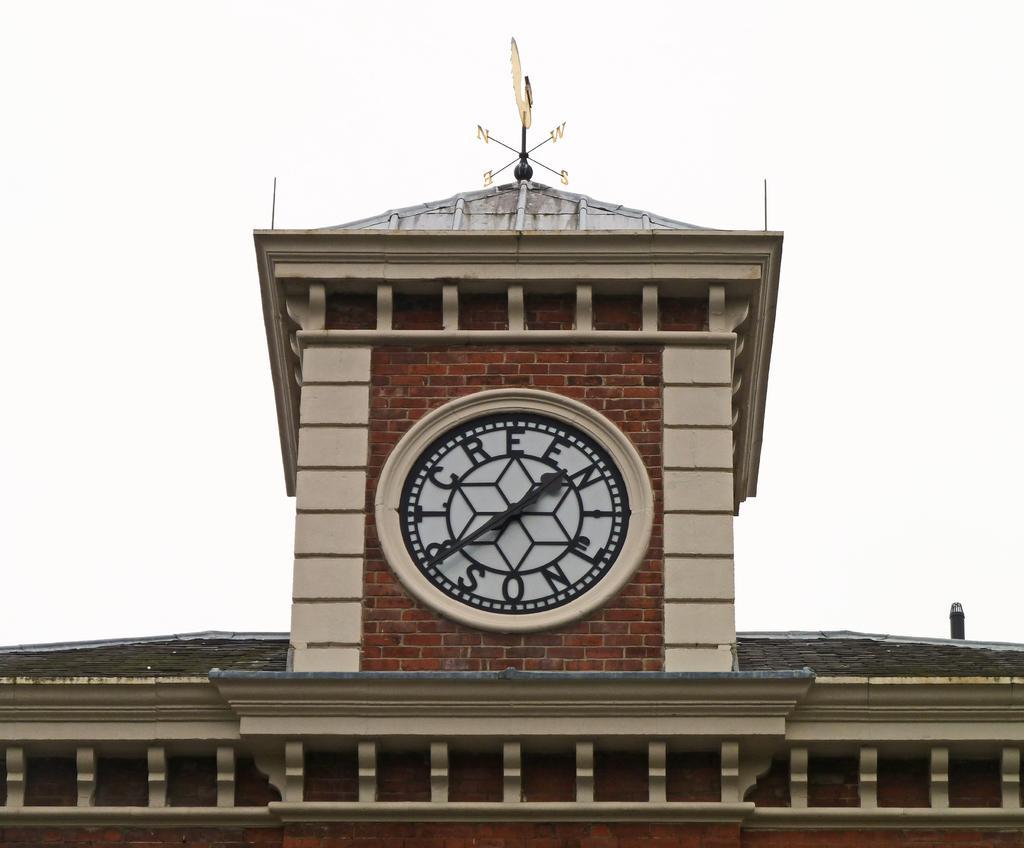Could you give a brief overview of what you see in this image? We can see clock on a wall,top of the building we can see navigation pole. In the background we can see sky. 